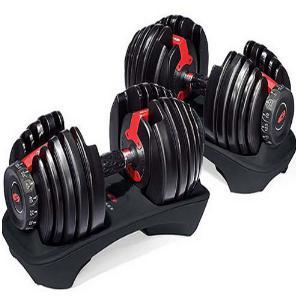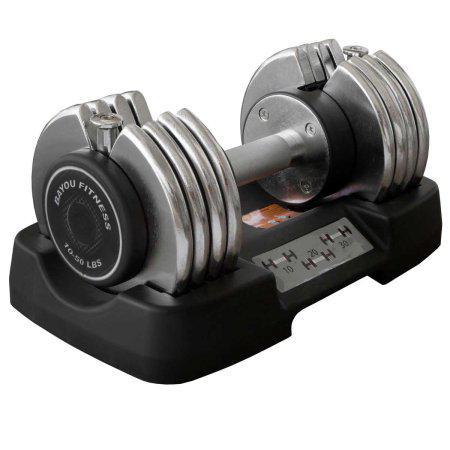The first image is the image on the left, the second image is the image on the right. For the images shown, is this caption "There are exactly three weights with no bars sticking out of them." true? Answer yes or no. Yes. The first image is the image on the left, the second image is the image on the right. For the images displayed, is the sentence "There are 3 dumbbells, and all of them are on storage trays." factually correct? Answer yes or no. Yes. 